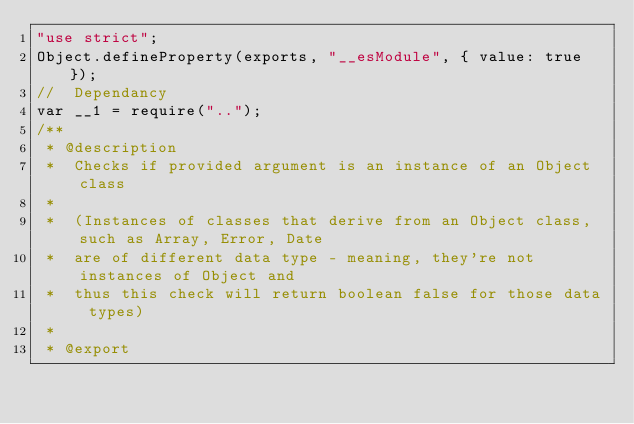<code> <loc_0><loc_0><loc_500><loc_500><_JavaScript_>"use strict";
Object.defineProperty(exports, "__esModule", { value: true });
//  Dependancy
var __1 = require("..");
/**
 * @description
 *  Checks if provided argument is an instance of an Object class
 *
 *  (Instances of classes that derive from an Object class, such as Array, Error, Date
 *  are of different data type - meaning, they're not instances of Object and
 *  thus this check will return boolean false for those data types)
 *
 * @export</code> 